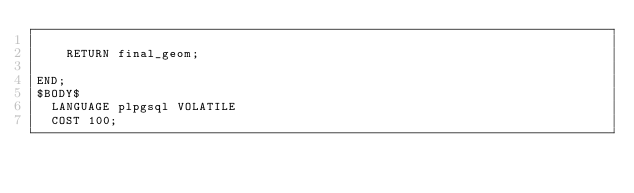<code> <loc_0><loc_0><loc_500><loc_500><_SQL_>
    RETURN final_geom;

END;
$BODY$
  LANGUAGE plpgsql VOLATILE
  COST 100;</code> 